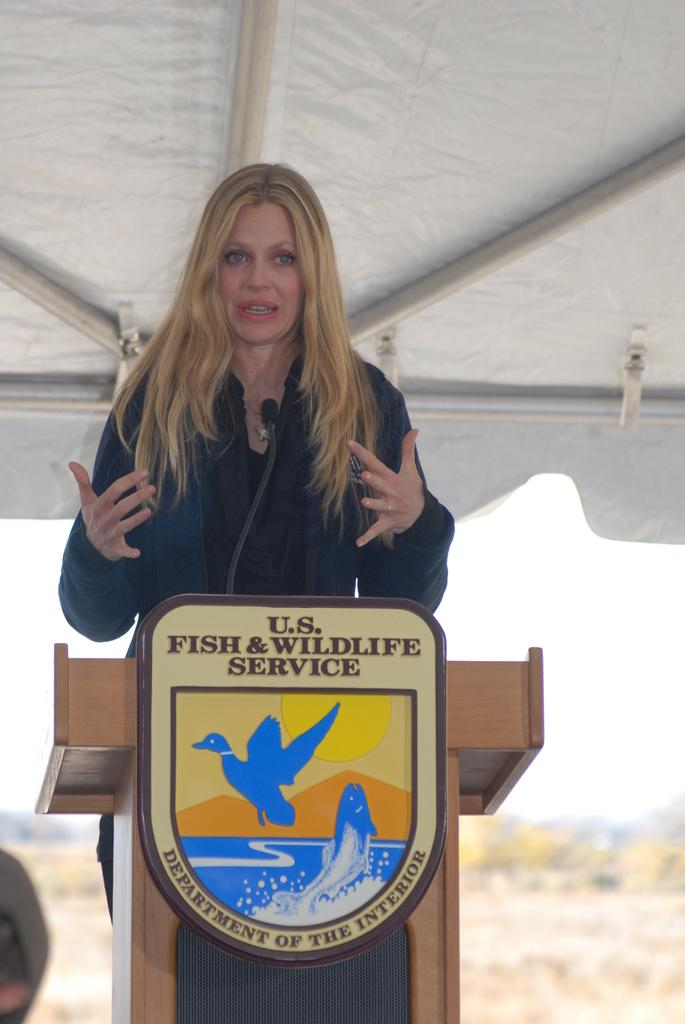<image>
Describe the image concisely. a woman standing in front of a sign that says u.s. fish & wildlife service 